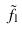<formula> <loc_0><loc_0><loc_500><loc_500>\tilde { f } _ { 1 }</formula> 